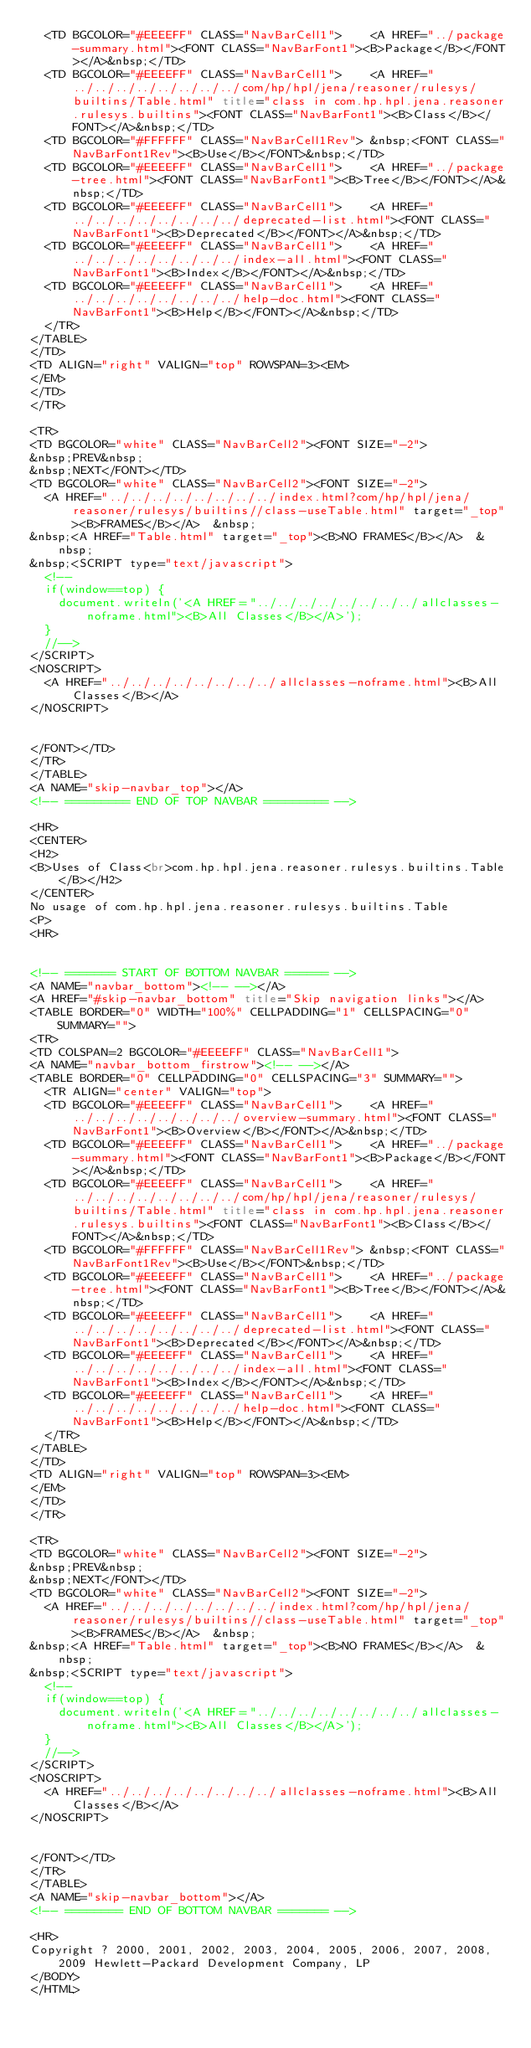<code> <loc_0><loc_0><loc_500><loc_500><_HTML_>  <TD BGCOLOR="#EEEEFF" CLASS="NavBarCell1">    <A HREF="../package-summary.html"><FONT CLASS="NavBarFont1"><B>Package</B></FONT></A>&nbsp;</TD>
  <TD BGCOLOR="#EEEEFF" CLASS="NavBarCell1">    <A HREF="../../../../../../../../com/hp/hpl/jena/reasoner/rulesys/builtins/Table.html" title="class in com.hp.hpl.jena.reasoner.rulesys.builtins"><FONT CLASS="NavBarFont1"><B>Class</B></FONT></A>&nbsp;</TD>
  <TD BGCOLOR="#FFFFFF" CLASS="NavBarCell1Rev"> &nbsp;<FONT CLASS="NavBarFont1Rev"><B>Use</B></FONT>&nbsp;</TD>
  <TD BGCOLOR="#EEEEFF" CLASS="NavBarCell1">    <A HREF="../package-tree.html"><FONT CLASS="NavBarFont1"><B>Tree</B></FONT></A>&nbsp;</TD>
  <TD BGCOLOR="#EEEEFF" CLASS="NavBarCell1">    <A HREF="../../../../../../../../deprecated-list.html"><FONT CLASS="NavBarFont1"><B>Deprecated</B></FONT></A>&nbsp;</TD>
  <TD BGCOLOR="#EEEEFF" CLASS="NavBarCell1">    <A HREF="../../../../../../../../index-all.html"><FONT CLASS="NavBarFont1"><B>Index</B></FONT></A>&nbsp;</TD>
  <TD BGCOLOR="#EEEEFF" CLASS="NavBarCell1">    <A HREF="../../../../../../../../help-doc.html"><FONT CLASS="NavBarFont1"><B>Help</B></FONT></A>&nbsp;</TD>
  </TR>
</TABLE>
</TD>
<TD ALIGN="right" VALIGN="top" ROWSPAN=3><EM>
</EM>
</TD>
</TR>

<TR>
<TD BGCOLOR="white" CLASS="NavBarCell2"><FONT SIZE="-2">
&nbsp;PREV&nbsp;
&nbsp;NEXT</FONT></TD>
<TD BGCOLOR="white" CLASS="NavBarCell2"><FONT SIZE="-2">
  <A HREF="../../../../../../../../index.html?com/hp/hpl/jena/reasoner/rulesys/builtins//class-useTable.html" target="_top"><B>FRAMES</B></A>  &nbsp;
&nbsp;<A HREF="Table.html" target="_top"><B>NO FRAMES</B></A>  &nbsp;
&nbsp;<SCRIPT type="text/javascript">
  <!--
  if(window==top) {
    document.writeln('<A HREF="../../../../../../../../allclasses-noframe.html"><B>All Classes</B></A>');
  }
  //-->
</SCRIPT>
<NOSCRIPT>
  <A HREF="../../../../../../../../allclasses-noframe.html"><B>All Classes</B></A>
</NOSCRIPT>


</FONT></TD>
</TR>
</TABLE>
<A NAME="skip-navbar_top"></A>
<!-- ========= END OF TOP NAVBAR ========= -->

<HR>
<CENTER>
<H2>
<B>Uses of Class<br>com.hp.hpl.jena.reasoner.rulesys.builtins.Table</B></H2>
</CENTER>
No usage of com.hp.hpl.jena.reasoner.rulesys.builtins.Table
<P>
<HR>


<!-- ======= START OF BOTTOM NAVBAR ====== -->
<A NAME="navbar_bottom"><!-- --></A>
<A HREF="#skip-navbar_bottom" title="Skip navigation links"></A>
<TABLE BORDER="0" WIDTH="100%" CELLPADDING="1" CELLSPACING="0" SUMMARY="">
<TR>
<TD COLSPAN=2 BGCOLOR="#EEEEFF" CLASS="NavBarCell1">
<A NAME="navbar_bottom_firstrow"><!-- --></A>
<TABLE BORDER="0" CELLPADDING="0" CELLSPACING="3" SUMMARY="">
  <TR ALIGN="center" VALIGN="top">
  <TD BGCOLOR="#EEEEFF" CLASS="NavBarCell1">    <A HREF="../../../../../../../../overview-summary.html"><FONT CLASS="NavBarFont1"><B>Overview</B></FONT></A>&nbsp;</TD>
  <TD BGCOLOR="#EEEEFF" CLASS="NavBarCell1">    <A HREF="../package-summary.html"><FONT CLASS="NavBarFont1"><B>Package</B></FONT></A>&nbsp;</TD>
  <TD BGCOLOR="#EEEEFF" CLASS="NavBarCell1">    <A HREF="../../../../../../../../com/hp/hpl/jena/reasoner/rulesys/builtins/Table.html" title="class in com.hp.hpl.jena.reasoner.rulesys.builtins"><FONT CLASS="NavBarFont1"><B>Class</B></FONT></A>&nbsp;</TD>
  <TD BGCOLOR="#FFFFFF" CLASS="NavBarCell1Rev"> &nbsp;<FONT CLASS="NavBarFont1Rev"><B>Use</B></FONT>&nbsp;</TD>
  <TD BGCOLOR="#EEEEFF" CLASS="NavBarCell1">    <A HREF="../package-tree.html"><FONT CLASS="NavBarFont1"><B>Tree</B></FONT></A>&nbsp;</TD>
  <TD BGCOLOR="#EEEEFF" CLASS="NavBarCell1">    <A HREF="../../../../../../../../deprecated-list.html"><FONT CLASS="NavBarFont1"><B>Deprecated</B></FONT></A>&nbsp;</TD>
  <TD BGCOLOR="#EEEEFF" CLASS="NavBarCell1">    <A HREF="../../../../../../../../index-all.html"><FONT CLASS="NavBarFont1"><B>Index</B></FONT></A>&nbsp;</TD>
  <TD BGCOLOR="#EEEEFF" CLASS="NavBarCell1">    <A HREF="../../../../../../../../help-doc.html"><FONT CLASS="NavBarFont1"><B>Help</B></FONT></A>&nbsp;</TD>
  </TR>
</TABLE>
</TD>
<TD ALIGN="right" VALIGN="top" ROWSPAN=3><EM>
</EM>
</TD>
</TR>

<TR>
<TD BGCOLOR="white" CLASS="NavBarCell2"><FONT SIZE="-2">
&nbsp;PREV&nbsp;
&nbsp;NEXT</FONT></TD>
<TD BGCOLOR="white" CLASS="NavBarCell2"><FONT SIZE="-2">
  <A HREF="../../../../../../../../index.html?com/hp/hpl/jena/reasoner/rulesys/builtins//class-useTable.html" target="_top"><B>FRAMES</B></A>  &nbsp;
&nbsp;<A HREF="Table.html" target="_top"><B>NO FRAMES</B></A>  &nbsp;
&nbsp;<SCRIPT type="text/javascript">
  <!--
  if(window==top) {
    document.writeln('<A HREF="../../../../../../../../allclasses-noframe.html"><B>All Classes</B></A>');
  }
  //-->
</SCRIPT>
<NOSCRIPT>
  <A HREF="../../../../../../../../allclasses-noframe.html"><B>All Classes</B></A>
</NOSCRIPT>


</FONT></TD>
</TR>
</TABLE>
<A NAME="skip-navbar_bottom"></A>
<!-- ======== END OF BOTTOM NAVBAR ======= -->

<HR>
Copyright ? 2000, 2001, 2002, 2003, 2004, 2005, 2006, 2007, 2008, 2009 Hewlett-Packard Development Company, LP
</BODY>
</HTML>
</code> 